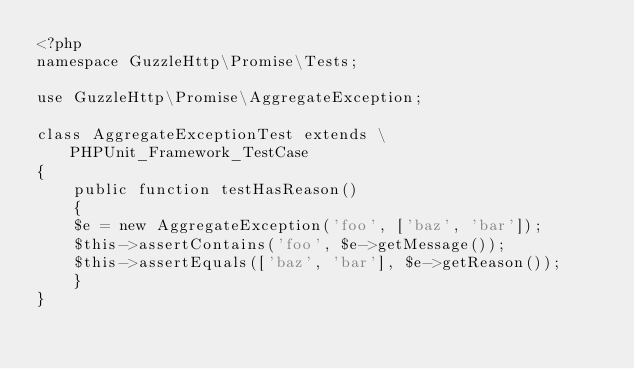Convert code to text. <code><loc_0><loc_0><loc_500><loc_500><_PHP_><?php
namespace GuzzleHttp\Promise\Tests;

use GuzzleHttp\Promise\AggregateException;

class AggregateExceptionTest extends \PHPUnit_Framework_TestCase
{
    public function testHasReason()
    {
    $e = new AggregateException('foo', ['baz', 'bar']);
    $this->assertContains('foo', $e->getMessage());
    $this->assertEquals(['baz', 'bar'], $e->getReason());
    }
}
</code> 